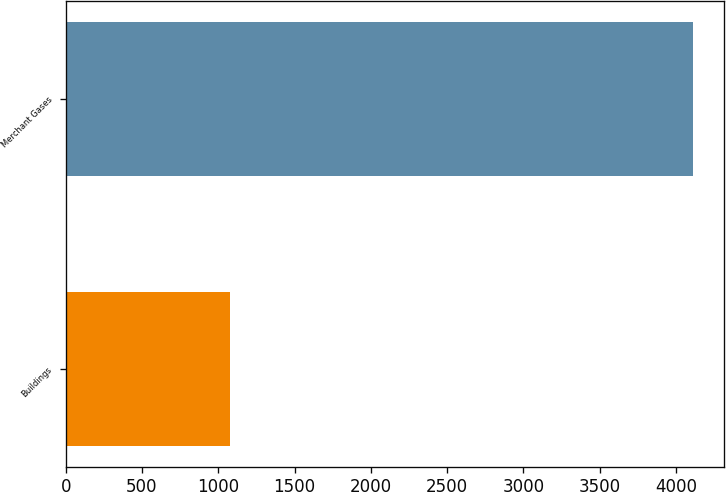Convert chart. <chart><loc_0><loc_0><loc_500><loc_500><bar_chart><fcel>Buildings<fcel>Merchant Gases<nl><fcel>1076.3<fcel>4109.1<nl></chart> 